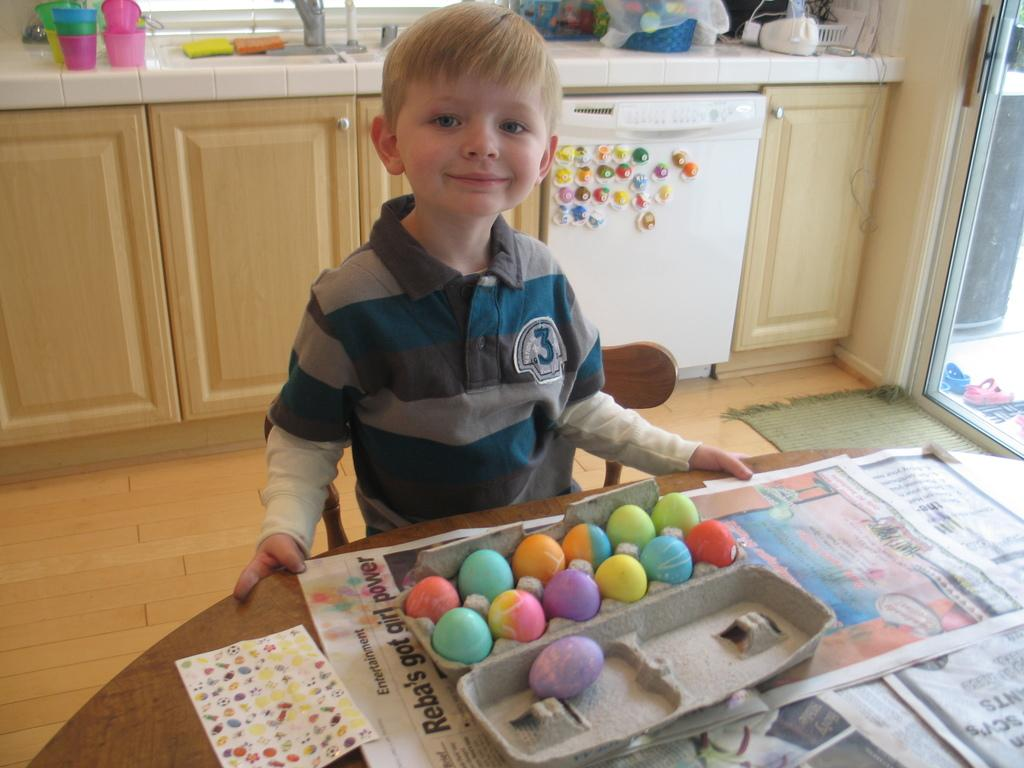What type of furniture is present in the image? There is a table in the image. What object can be seen on the table? There are newspapers on the table. What is the boy in the image doing? The boy is standing in the image. What type of storage units are in the image? There are cupboards in the image. What is used for washing in the image? There is a sink in the image. What type of dishware is present in the image? There are glasses in the image. What type of entryway is in the image? There is a door in the image. What type of art is the boy creating in the image? There is no art or indication of the boy creating art in the image. What type of quiver is the boy holding in the image? There is no quiver present in the image. 